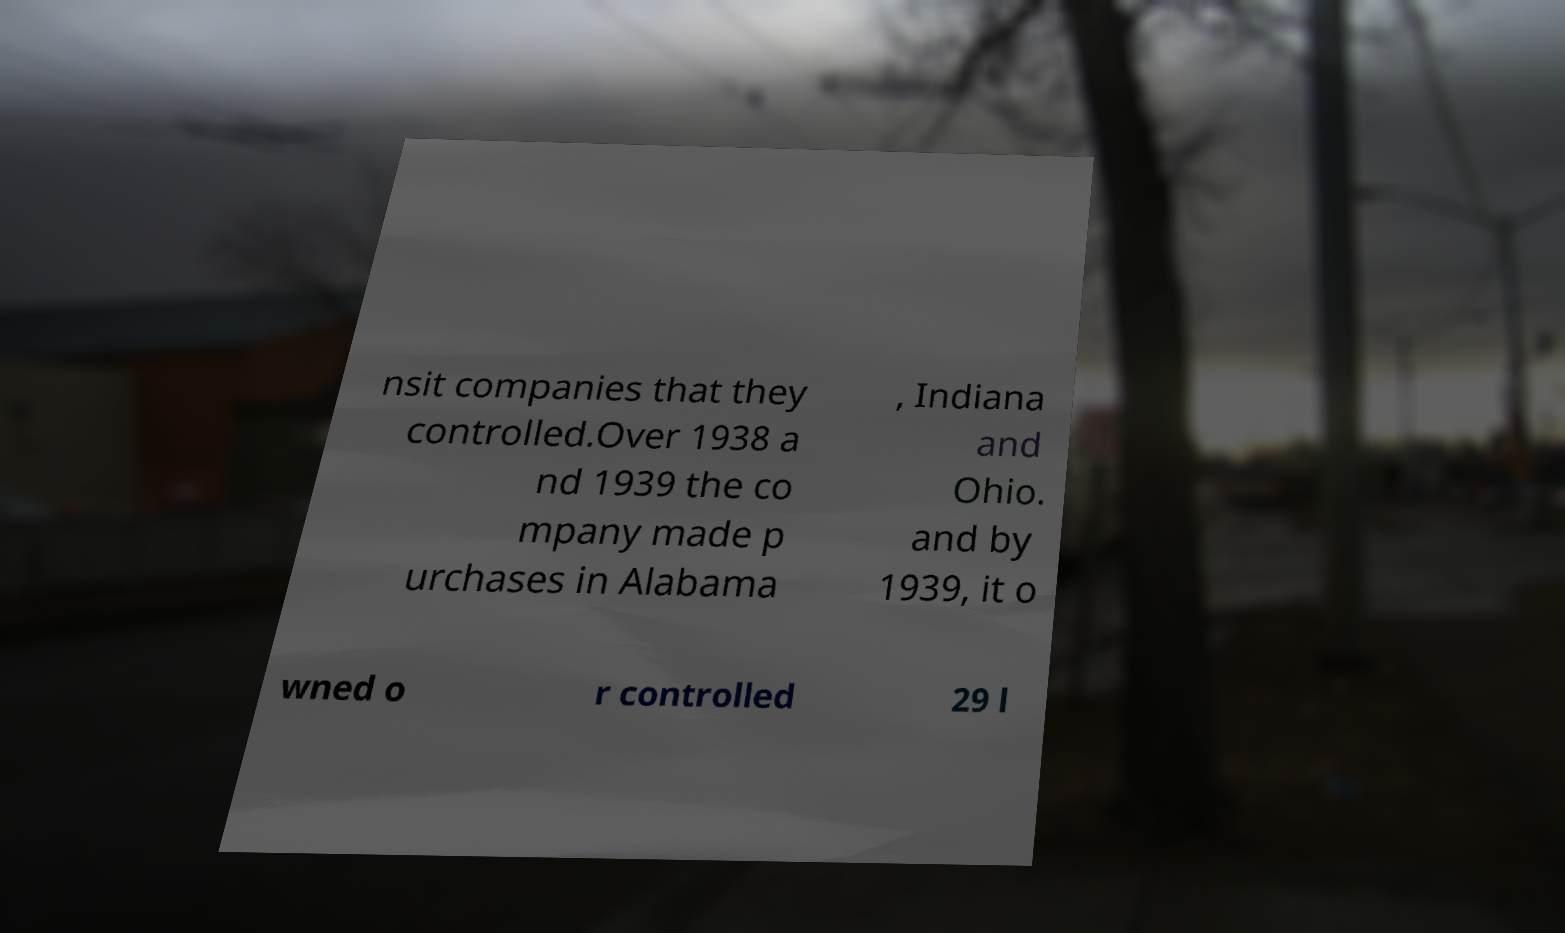I need the written content from this picture converted into text. Can you do that? nsit companies that they controlled.Over 1938 a nd 1939 the co mpany made p urchases in Alabama , Indiana and Ohio. and by 1939, it o wned o r controlled 29 l 